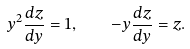Convert formula to latex. <formula><loc_0><loc_0><loc_500><loc_500>y ^ { 2 } \frac { d z } { d y } = 1 , \quad - y \frac { d z } { d y } = z .</formula> 